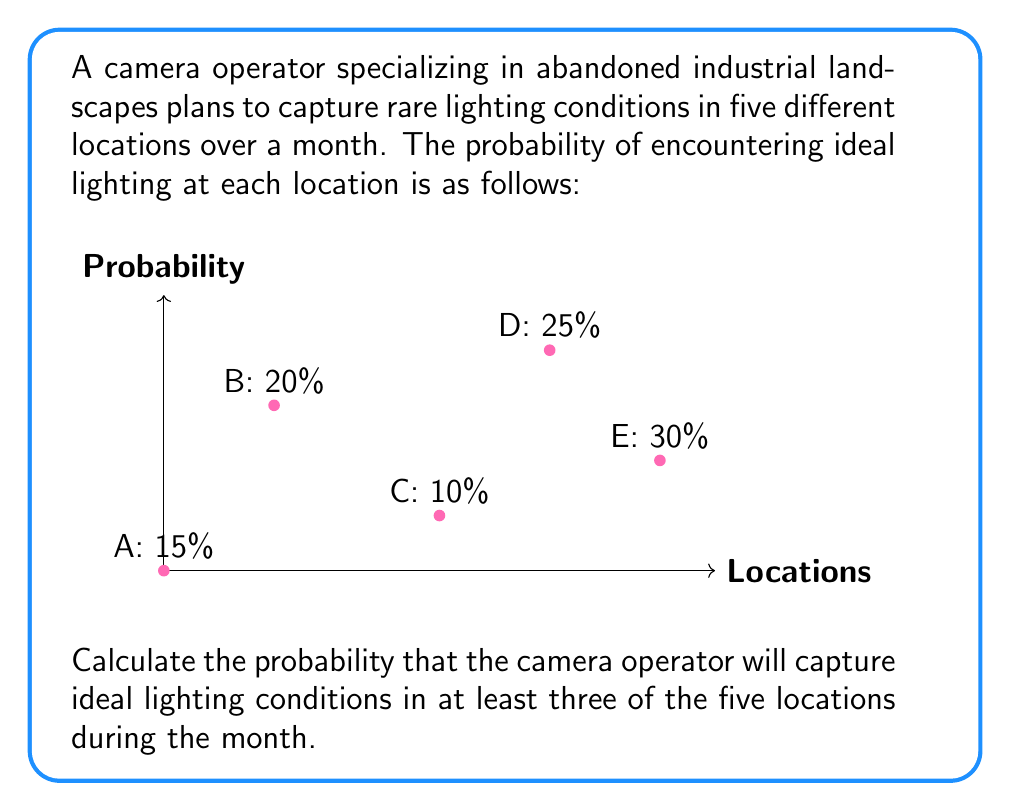Teach me how to tackle this problem. To solve this problem, we'll use the concept of binomial probability. Let's approach this step-by-step:

1) First, we need to calculate the probability of success (capturing ideal lighting) and failure for each trial:
   $p = (0.15 + 0.20 + 0.10 + 0.25 + 0.30) / 5 = 0.20$
   $q = 1 - p = 0.80$

2) We want the probability of at least 3 successes out of 5 trials. This means we need to calculate the probability of 3, 4, or 5 successes and sum them up.

3) We'll use the binomial probability formula:
   $$P(X = k) = \binom{n}{k} p^k q^{n-k}$$
   where $n$ is the number of trials, $k$ is the number of successes, $p$ is the probability of success, and $q$ is the probability of failure.

4) Let's calculate for each case:

   For 3 successes: $P(X = 3) = \binom{5}{3} (0.20)^3 (0.80)^2 = 10 \times 0.008 \times 0.64 = 0.0512$

   For 4 successes: $P(X = 4) = \binom{5}{4} (0.20)^4 (0.80)^1 = 5 \times 0.0016 \times 0.80 = 0.0064$

   For 5 successes: $P(X = 5) = \binom{5}{5} (0.20)^5 (0.80)^0 = 1 \times 0.00032 \times 1 = 0.00032$

5) Now, we sum these probabilities:
   $P(X \geq 3) = 0.0512 + 0.0064 + 0.00032 = 0.05792$

6) Therefore, the probability of capturing ideal lighting conditions in at least three of the five locations is approximately 0.05792 or 5.792%.
Answer: 0.05792 or 5.792% 